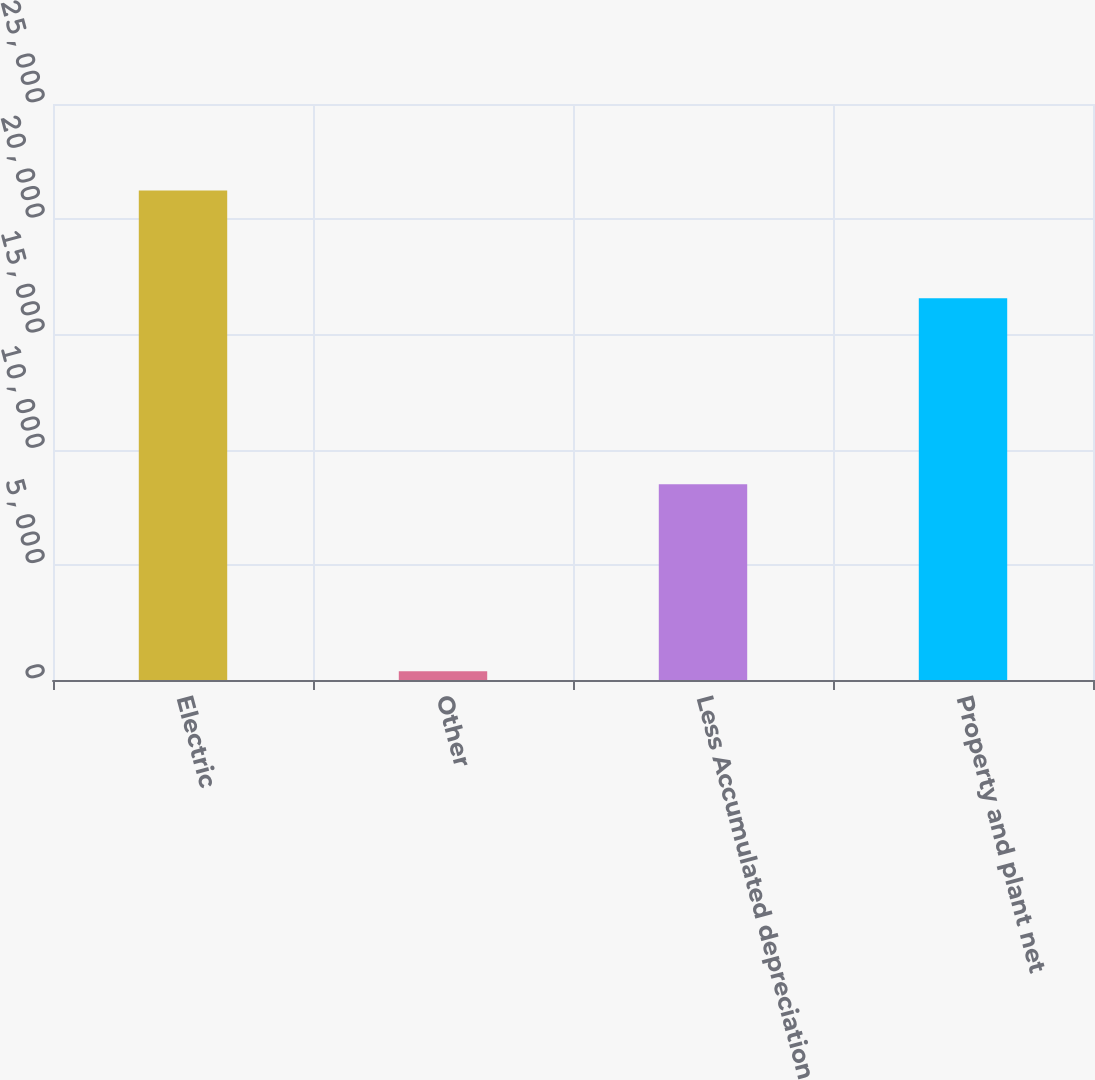<chart> <loc_0><loc_0><loc_500><loc_500><bar_chart><fcel>Electric<fcel>Other<fcel>Less Accumulated depreciation<fcel>Property and plant net<nl><fcel>21244<fcel>381<fcel>8499<fcel>16567<nl></chart> 